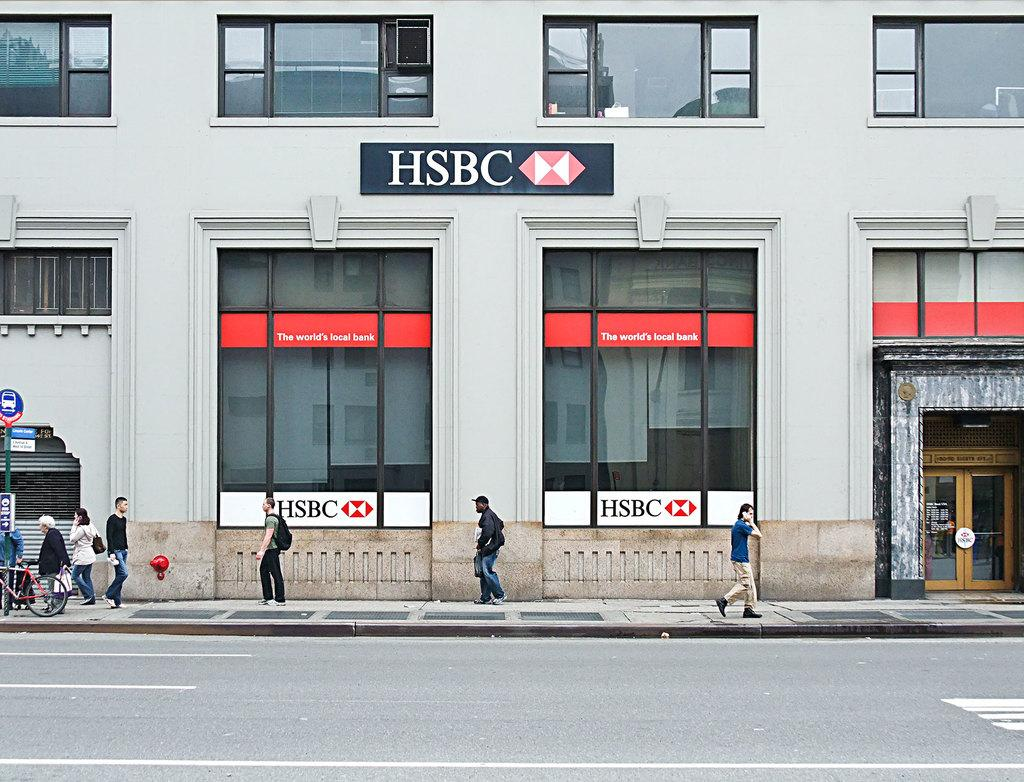Provide a one-sentence caption for the provided image. People are walking on the streets in front of an HSBC building. 